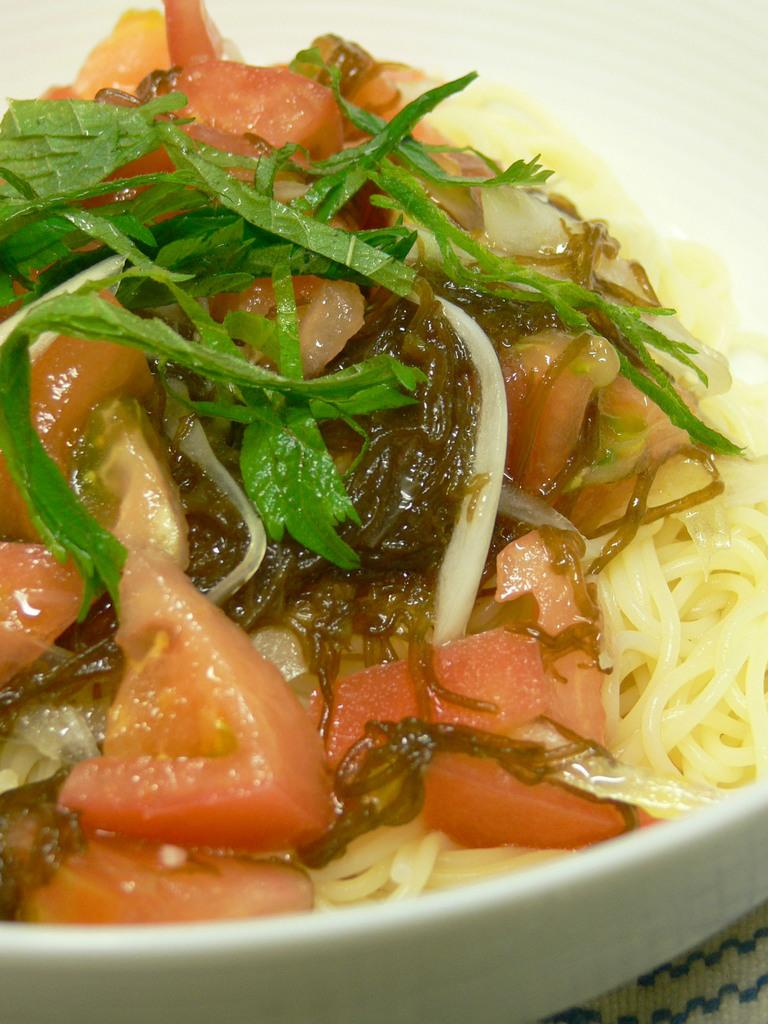What is in the bowl that is visible in the image? There is a bowl containing food in the image. How is the food in the bowl decorated or garnished? The food is garnished with green leaves. What type of stew is being prepared in the image? There is no stew present in the image, and the food in the bowl is not specified as a stew. How does the baseball interact with the food in the image? There is no baseball present in the image, so it cannot interact with the food. 